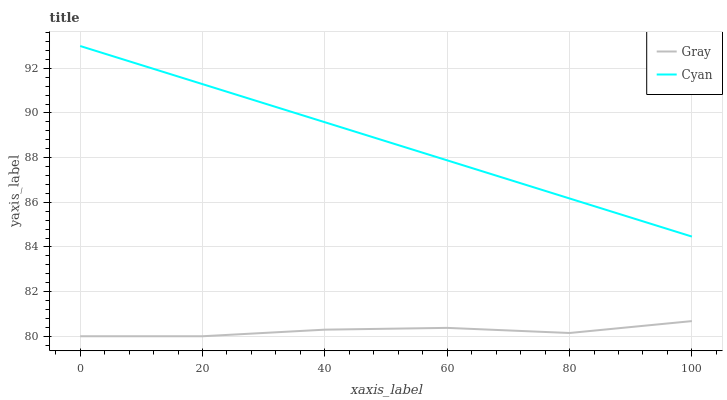Does Gray have the minimum area under the curve?
Answer yes or no. Yes. Does Cyan have the maximum area under the curve?
Answer yes or no. Yes. Does Cyan have the minimum area under the curve?
Answer yes or no. No. Is Cyan the smoothest?
Answer yes or no. Yes. Is Gray the roughest?
Answer yes or no. Yes. Is Cyan the roughest?
Answer yes or no. No. Does Cyan have the lowest value?
Answer yes or no. No. Does Cyan have the highest value?
Answer yes or no. Yes. Is Gray less than Cyan?
Answer yes or no. Yes. Is Cyan greater than Gray?
Answer yes or no. Yes. Does Gray intersect Cyan?
Answer yes or no. No. 